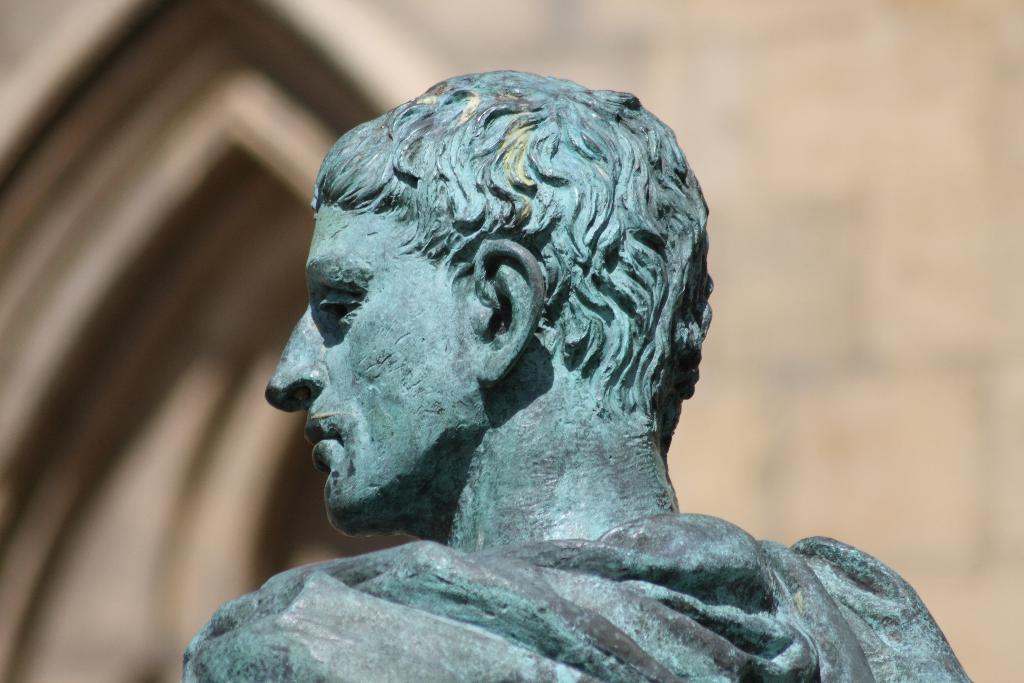Could you give a brief overview of what you see in this image? In this image we can see a statue. 